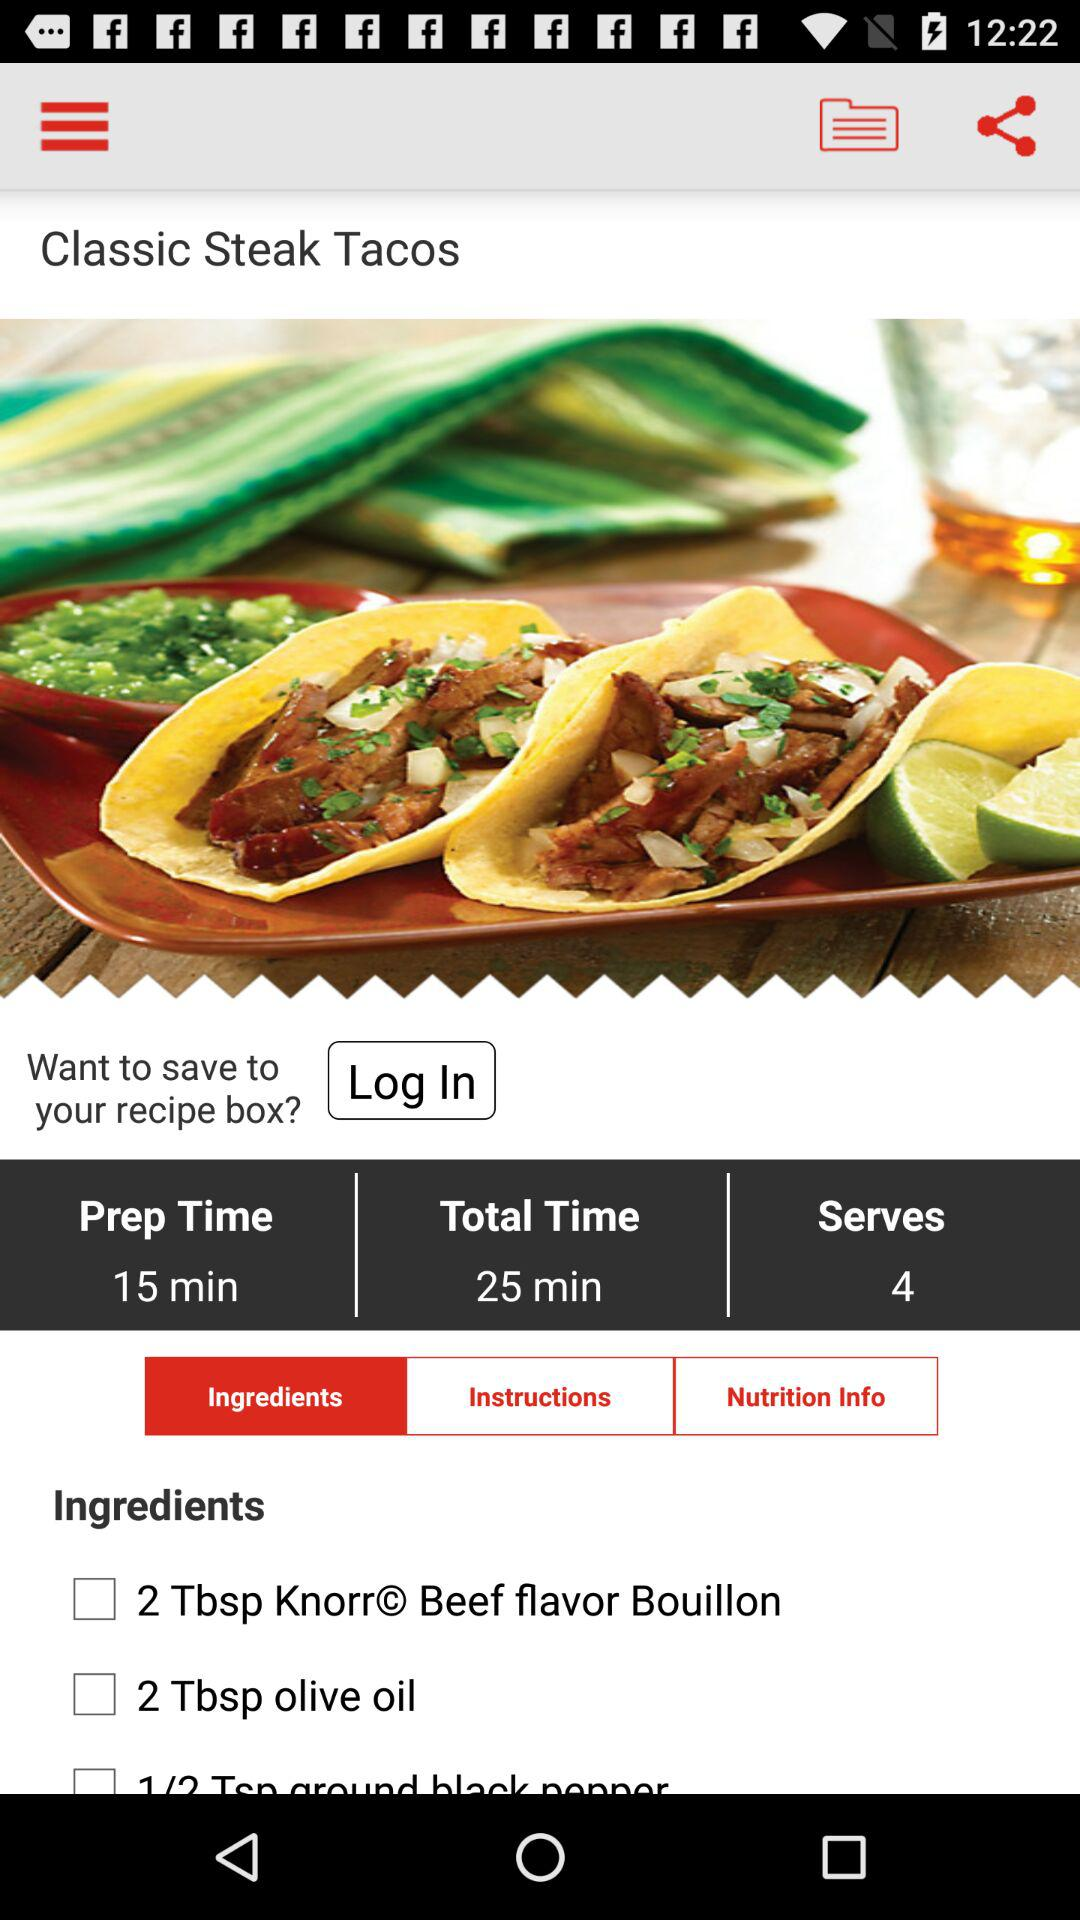Which tab is selected? The selected tab is "Ingredients". 